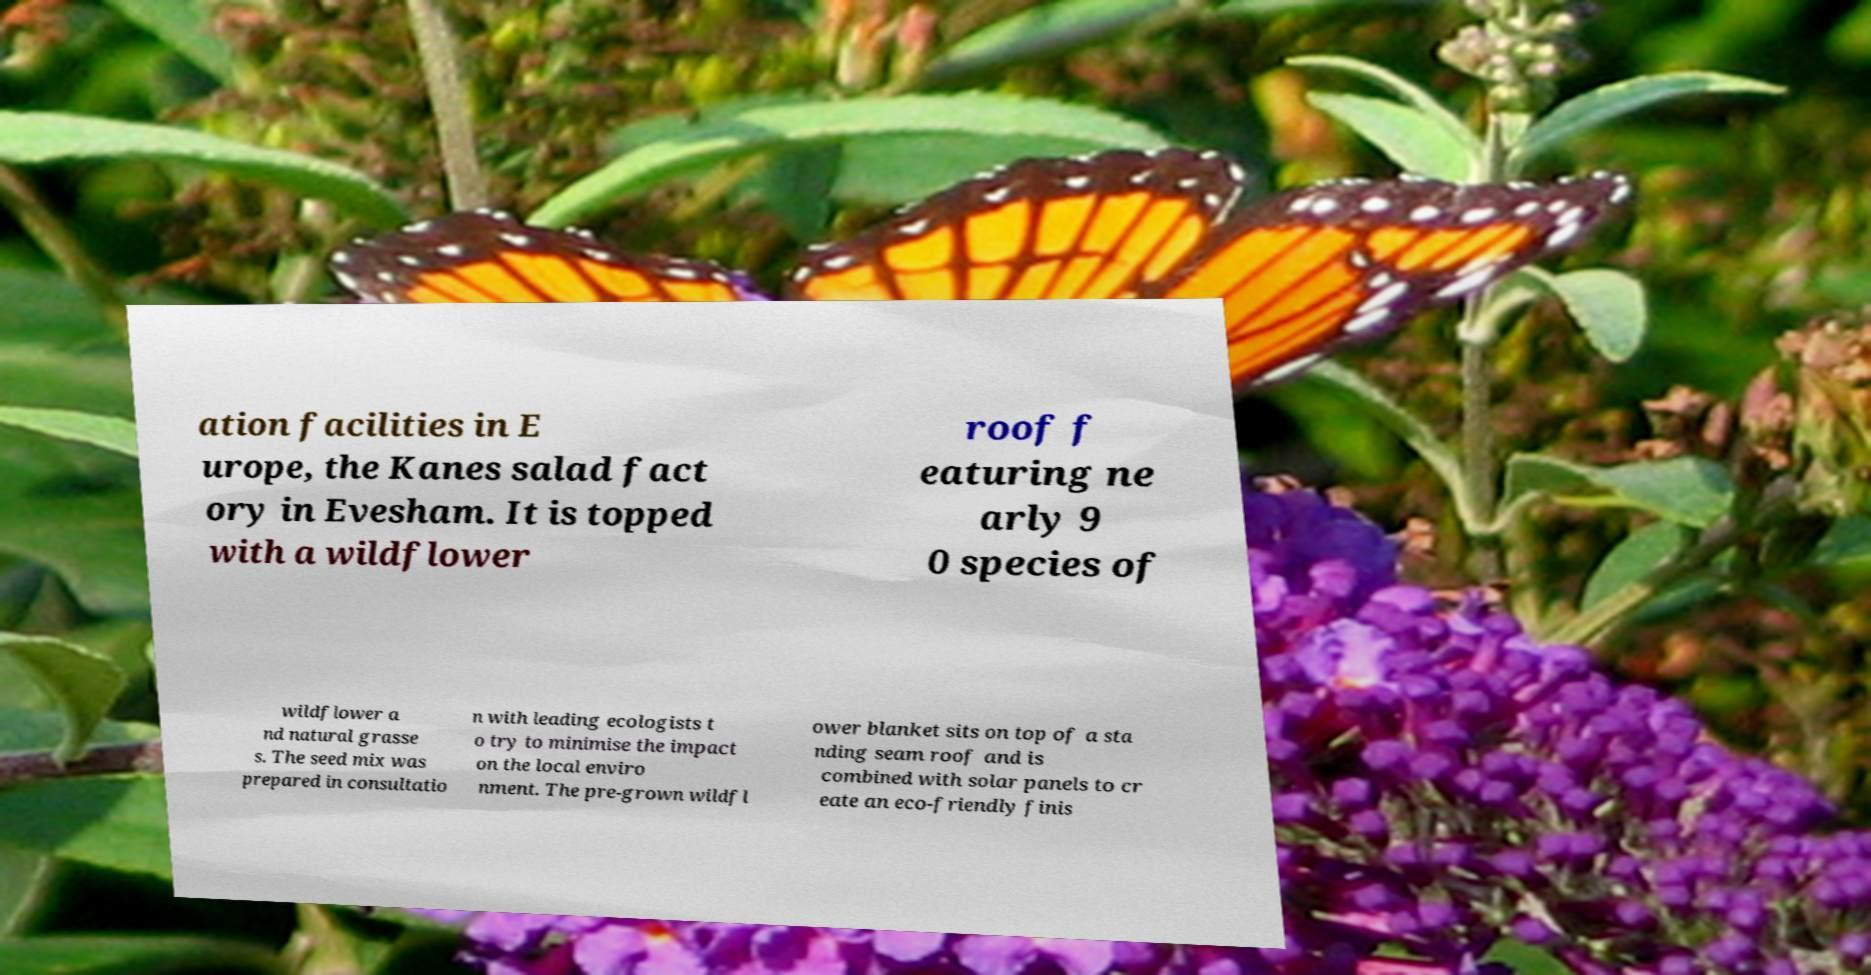I need the written content from this picture converted into text. Can you do that? ation facilities in E urope, the Kanes salad fact ory in Evesham. It is topped with a wildflower roof f eaturing ne arly 9 0 species of wildflower a nd natural grasse s. The seed mix was prepared in consultatio n with leading ecologists t o try to minimise the impact on the local enviro nment. The pre-grown wildfl ower blanket sits on top of a sta nding seam roof and is combined with solar panels to cr eate an eco-friendly finis 